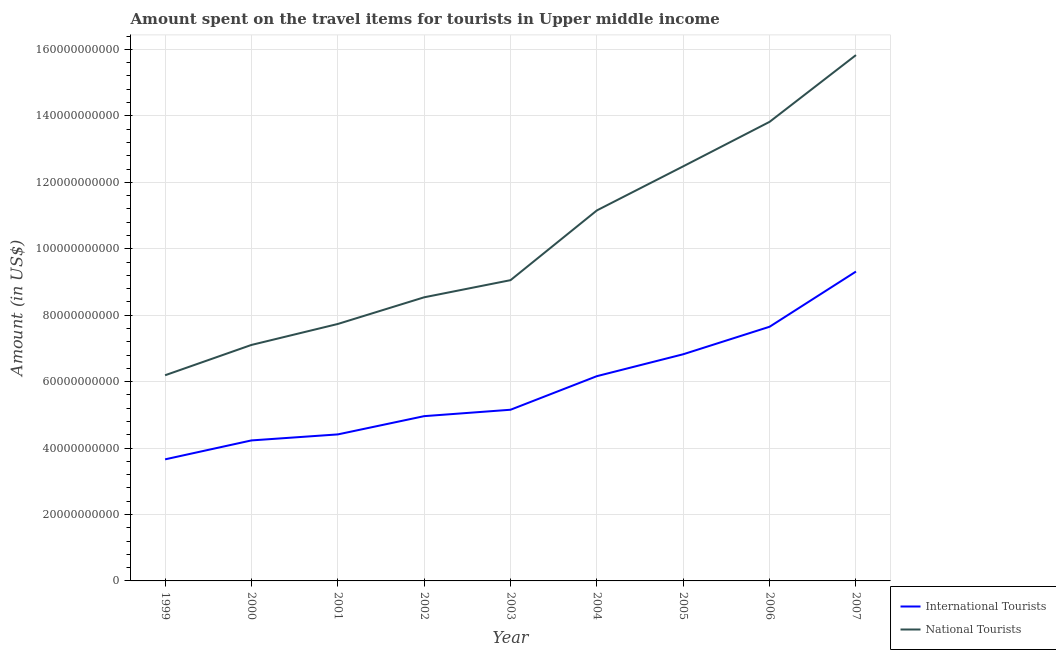Does the line corresponding to amount spent on travel items of national tourists intersect with the line corresponding to amount spent on travel items of international tourists?
Your answer should be compact. No. Is the number of lines equal to the number of legend labels?
Your answer should be compact. Yes. What is the amount spent on travel items of national tourists in 1999?
Ensure brevity in your answer.  6.19e+1. Across all years, what is the maximum amount spent on travel items of national tourists?
Make the answer very short. 1.58e+11. Across all years, what is the minimum amount spent on travel items of international tourists?
Give a very brief answer. 3.66e+1. In which year was the amount spent on travel items of international tourists maximum?
Make the answer very short. 2007. What is the total amount spent on travel items of international tourists in the graph?
Keep it short and to the point. 5.24e+11. What is the difference between the amount spent on travel items of national tourists in 2000 and that in 2002?
Provide a succinct answer. -1.43e+1. What is the difference between the amount spent on travel items of national tourists in 1999 and the amount spent on travel items of international tourists in 2000?
Offer a very short reply. 1.96e+1. What is the average amount spent on travel items of national tourists per year?
Provide a succinct answer. 1.02e+11. In the year 2003, what is the difference between the amount spent on travel items of international tourists and amount spent on travel items of national tourists?
Keep it short and to the point. -3.90e+1. What is the ratio of the amount spent on travel items of national tourists in 2003 to that in 2004?
Provide a short and direct response. 0.81. Is the difference between the amount spent on travel items of national tourists in 1999 and 2003 greater than the difference between the amount spent on travel items of international tourists in 1999 and 2003?
Ensure brevity in your answer.  No. What is the difference between the highest and the second highest amount spent on travel items of international tourists?
Your answer should be compact. 1.66e+1. What is the difference between the highest and the lowest amount spent on travel items of international tourists?
Give a very brief answer. 5.65e+1. Is the sum of the amount spent on travel items of national tourists in 2002 and 2006 greater than the maximum amount spent on travel items of international tourists across all years?
Ensure brevity in your answer.  Yes. Is the amount spent on travel items of international tourists strictly greater than the amount spent on travel items of national tourists over the years?
Offer a very short reply. No. How many lines are there?
Ensure brevity in your answer.  2. Are the values on the major ticks of Y-axis written in scientific E-notation?
Your answer should be compact. No. Does the graph contain grids?
Provide a short and direct response. Yes. What is the title of the graph?
Offer a terse response. Amount spent on the travel items for tourists in Upper middle income. What is the Amount (in US$) of International Tourists in 1999?
Ensure brevity in your answer.  3.66e+1. What is the Amount (in US$) of National Tourists in 1999?
Offer a very short reply. 6.19e+1. What is the Amount (in US$) of International Tourists in 2000?
Your response must be concise. 4.23e+1. What is the Amount (in US$) of National Tourists in 2000?
Offer a very short reply. 7.10e+1. What is the Amount (in US$) in International Tourists in 2001?
Ensure brevity in your answer.  4.41e+1. What is the Amount (in US$) in National Tourists in 2001?
Offer a very short reply. 7.74e+1. What is the Amount (in US$) in International Tourists in 2002?
Offer a very short reply. 4.96e+1. What is the Amount (in US$) in National Tourists in 2002?
Ensure brevity in your answer.  8.54e+1. What is the Amount (in US$) of International Tourists in 2003?
Offer a very short reply. 5.15e+1. What is the Amount (in US$) of National Tourists in 2003?
Offer a terse response. 9.05e+1. What is the Amount (in US$) in International Tourists in 2004?
Provide a short and direct response. 6.16e+1. What is the Amount (in US$) in National Tourists in 2004?
Make the answer very short. 1.12e+11. What is the Amount (in US$) of International Tourists in 2005?
Offer a very short reply. 6.82e+1. What is the Amount (in US$) in National Tourists in 2005?
Provide a succinct answer. 1.25e+11. What is the Amount (in US$) of International Tourists in 2006?
Provide a short and direct response. 7.65e+1. What is the Amount (in US$) of National Tourists in 2006?
Keep it short and to the point. 1.38e+11. What is the Amount (in US$) of International Tourists in 2007?
Your answer should be very brief. 9.31e+1. What is the Amount (in US$) of National Tourists in 2007?
Provide a succinct answer. 1.58e+11. Across all years, what is the maximum Amount (in US$) of International Tourists?
Your answer should be very brief. 9.31e+1. Across all years, what is the maximum Amount (in US$) of National Tourists?
Offer a very short reply. 1.58e+11. Across all years, what is the minimum Amount (in US$) of International Tourists?
Give a very brief answer. 3.66e+1. Across all years, what is the minimum Amount (in US$) in National Tourists?
Ensure brevity in your answer.  6.19e+1. What is the total Amount (in US$) of International Tourists in the graph?
Ensure brevity in your answer.  5.24e+11. What is the total Amount (in US$) of National Tourists in the graph?
Give a very brief answer. 9.19e+11. What is the difference between the Amount (in US$) of International Tourists in 1999 and that in 2000?
Your answer should be very brief. -5.70e+09. What is the difference between the Amount (in US$) of National Tourists in 1999 and that in 2000?
Keep it short and to the point. -9.13e+09. What is the difference between the Amount (in US$) of International Tourists in 1999 and that in 2001?
Offer a very short reply. -7.51e+09. What is the difference between the Amount (in US$) in National Tourists in 1999 and that in 2001?
Keep it short and to the point. -1.54e+1. What is the difference between the Amount (in US$) of International Tourists in 1999 and that in 2002?
Your answer should be very brief. -1.30e+1. What is the difference between the Amount (in US$) in National Tourists in 1999 and that in 2002?
Your response must be concise. -2.35e+1. What is the difference between the Amount (in US$) of International Tourists in 1999 and that in 2003?
Offer a very short reply. -1.49e+1. What is the difference between the Amount (in US$) of National Tourists in 1999 and that in 2003?
Keep it short and to the point. -2.86e+1. What is the difference between the Amount (in US$) of International Tourists in 1999 and that in 2004?
Keep it short and to the point. -2.50e+1. What is the difference between the Amount (in US$) of National Tourists in 1999 and that in 2004?
Make the answer very short. -4.96e+1. What is the difference between the Amount (in US$) in International Tourists in 1999 and that in 2005?
Make the answer very short. -3.16e+1. What is the difference between the Amount (in US$) of National Tourists in 1999 and that in 2005?
Offer a terse response. -6.29e+1. What is the difference between the Amount (in US$) of International Tourists in 1999 and that in 2006?
Ensure brevity in your answer.  -3.99e+1. What is the difference between the Amount (in US$) in National Tourists in 1999 and that in 2006?
Ensure brevity in your answer.  -7.63e+1. What is the difference between the Amount (in US$) in International Tourists in 1999 and that in 2007?
Your answer should be compact. -5.65e+1. What is the difference between the Amount (in US$) in National Tourists in 1999 and that in 2007?
Provide a succinct answer. -9.64e+1. What is the difference between the Amount (in US$) of International Tourists in 2000 and that in 2001?
Your answer should be compact. -1.81e+09. What is the difference between the Amount (in US$) of National Tourists in 2000 and that in 2001?
Keep it short and to the point. -6.31e+09. What is the difference between the Amount (in US$) in International Tourists in 2000 and that in 2002?
Ensure brevity in your answer.  -7.31e+09. What is the difference between the Amount (in US$) of National Tourists in 2000 and that in 2002?
Ensure brevity in your answer.  -1.43e+1. What is the difference between the Amount (in US$) of International Tourists in 2000 and that in 2003?
Keep it short and to the point. -9.23e+09. What is the difference between the Amount (in US$) of National Tourists in 2000 and that in 2003?
Offer a very short reply. -1.95e+1. What is the difference between the Amount (in US$) of International Tourists in 2000 and that in 2004?
Your answer should be very brief. -1.93e+1. What is the difference between the Amount (in US$) of National Tourists in 2000 and that in 2004?
Ensure brevity in your answer.  -4.05e+1. What is the difference between the Amount (in US$) in International Tourists in 2000 and that in 2005?
Provide a short and direct response. -2.59e+1. What is the difference between the Amount (in US$) of National Tourists in 2000 and that in 2005?
Your answer should be very brief. -5.38e+1. What is the difference between the Amount (in US$) of International Tourists in 2000 and that in 2006?
Provide a succinct answer. -3.42e+1. What is the difference between the Amount (in US$) of National Tourists in 2000 and that in 2006?
Offer a very short reply. -6.72e+1. What is the difference between the Amount (in US$) of International Tourists in 2000 and that in 2007?
Provide a short and direct response. -5.08e+1. What is the difference between the Amount (in US$) of National Tourists in 2000 and that in 2007?
Your response must be concise. -8.73e+1. What is the difference between the Amount (in US$) of International Tourists in 2001 and that in 2002?
Provide a succinct answer. -5.50e+09. What is the difference between the Amount (in US$) of National Tourists in 2001 and that in 2002?
Keep it short and to the point. -8.03e+09. What is the difference between the Amount (in US$) of International Tourists in 2001 and that in 2003?
Offer a very short reply. -7.43e+09. What is the difference between the Amount (in US$) of National Tourists in 2001 and that in 2003?
Make the answer very short. -1.32e+1. What is the difference between the Amount (in US$) in International Tourists in 2001 and that in 2004?
Your response must be concise. -1.75e+1. What is the difference between the Amount (in US$) of National Tourists in 2001 and that in 2004?
Give a very brief answer. -3.42e+1. What is the difference between the Amount (in US$) in International Tourists in 2001 and that in 2005?
Give a very brief answer. -2.41e+1. What is the difference between the Amount (in US$) of National Tourists in 2001 and that in 2005?
Keep it short and to the point. -4.75e+1. What is the difference between the Amount (in US$) in International Tourists in 2001 and that in 2006?
Your answer should be compact. -3.24e+1. What is the difference between the Amount (in US$) in National Tourists in 2001 and that in 2006?
Ensure brevity in your answer.  -6.09e+1. What is the difference between the Amount (in US$) in International Tourists in 2001 and that in 2007?
Your answer should be very brief. -4.90e+1. What is the difference between the Amount (in US$) in National Tourists in 2001 and that in 2007?
Offer a terse response. -8.09e+1. What is the difference between the Amount (in US$) of International Tourists in 2002 and that in 2003?
Your answer should be very brief. -1.93e+09. What is the difference between the Amount (in US$) of National Tourists in 2002 and that in 2003?
Ensure brevity in your answer.  -5.16e+09. What is the difference between the Amount (in US$) of International Tourists in 2002 and that in 2004?
Your answer should be compact. -1.20e+1. What is the difference between the Amount (in US$) of National Tourists in 2002 and that in 2004?
Ensure brevity in your answer.  -2.62e+1. What is the difference between the Amount (in US$) in International Tourists in 2002 and that in 2005?
Ensure brevity in your answer.  -1.86e+1. What is the difference between the Amount (in US$) of National Tourists in 2002 and that in 2005?
Ensure brevity in your answer.  -3.94e+1. What is the difference between the Amount (in US$) in International Tourists in 2002 and that in 2006?
Your answer should be very brief. -2.69e+1. What is the difference between the Amount (in US$) of National Tourists in 2002 and that in 2006?
Provide a succinct answer. -5.28e+1. What is the difference between the Amount (in US$) in International Tourists in 2002 and that in 2007?
Keep it short and to the point. -4.35e+1. What is the difference between the Amount (in US$) of National Tourists in 2002 and that in 2007?
Your answer should be compact. -7.29e+1. What is the difference between the Amount (in US$) in International Tourists in 2003 and that in 2004?
Provide a succinct answer. -1.01e+1. What is the difference between the Amount (in US$) of National Tourists in 2003 and that in 2004?
Offer a terse response. -2.10e+1. What is the difference between the Amount (in US$) of International Tourists in 2003 and that in 2005?
Offer a terse response. -1.67e+1. What is the difference between the Amount (in US$) in National Tourists in 2003 and that in 2005?
Offer a terse response. -3.43e+1. What is the difference between the Amount (in US$) of International Tourists in 2003 and that in 2006?
Make the answer very short. -2.50e+1. What is the difference between the Amount (in US$) of National Tourists in 2003 and that in 2006?
Keep it short and to the point. -4.77e+1. What is the difference between the Amount (in US$) of International Tourists in 2003 and that in 2007?
Make the answer very short. -4.16e+1. What is the difference between the Amount (in US$) in National Tourists in 2003 and that in 2007?
Provide a succinct answer. -6.78e+1. What is the difference between the Amount (in US$) of International Tourists in 2004 and that in 2005?
Keep it short and to the point. -6.59e+09. What is the difference between the Amount (in US$) in National Tourists in 2004 and that in 2005?
Your answer should be compact. -1.33e+1. What is the difference between the Amount (in US$) of International Tourists in 2004 and that in 2006?
Provide a succinct answer. -1.49e+1. What is the difference between the Amount (in US$) in National Tourists in 2004 and that in 2006?
Offer a very short reply. -2.67e+1. What is the difference between the Amount (in US$) in International Tourists in 2004 and that in 2007?
Your response must be concise. -3.15e+1. What is the difference between the Amount (in US$) of National Tourists in 2004 and that in 2007?
Ensure brevity in your answer.  -4.68e+1. What is the difference between the Amount (in US$) in International Tourists in 2005 and that in 2006?
Your answer should be compact. -8.28e+09. What is the difference between the Amount (in US$) in National Tourists in 2005 and that in 2006?
Give a very brief answer. -1.34e+1. What is the difference between the Amount (in US$) of International Tourists in 2005 and that in 2007?
Keep it short and to the point. -2.49e+1. What is the difference between the Amount (in US$) of National Tourists in 2005 and that in 2007?
Your answer should be compact. -3.35e+1. What is the difference between the Amount (in US$) of International Tourists in 2006 and that in 2007?
Ensure brevity in your answer.  -1.66e+1. What is the difference between the Amount (in US$) in National Tourists in 2006 and that in 2007?
Keep it short and to the point. -2.01e+1. What is the difference between the Amount (in US$) of International Tourists in 1999 and the Amount (in US$) of National Tourists in 2000?
Provide a short and direct response. -3.44e+1. What is the difference between the Amount (in US$) in International Tourists in 1999 and the Amount (in US$) in National Tourists in 2001?
Make the answer very short. -4.08e+1. What is the difference between the Amount (in US$) in International Tourists in 1999 and the Amount (in US$) in National Tourists in 2002?
Your answer should be very brief. -4.88e+1. What is the difference between the Amount (in US$) in International Tourists in 1999 and the Amount (in US$) in National Tourists in 2003?
Provide a succinct answer. -5.39e+1. What is the difference between the Amount (in US$) in International Tourists in 1999 and the Amount (in US$) in National Tourists in 2004?
Give a very brief answer. -7.49e+1. What is the difference between the Amount (in US$) in International Tourists in 1999 and the Amount (in US$) in National Tourists in 2005?
Provide a succinct answer. -8.82e+1. What is the difference between the Amount (in US$) in International Tourists in 1999 and the Amount (in US$) in National Tourists in 2006?
Your answer should be compact. -1.02e+11. What is the difference between the Amount (in US$) in International Tourists in 1999 and the Amount (in US$) in National Tourists in 2007?
Your answer should be compact. -1.22e+11. What is the difference between the Amount (in US$) in International Tourists in 2000 and the Amount (in US$) in National Tourists in 2001?
Make the answer very short. -3.51e+1. What is the difference between the Amount (in US$) in International Tourists in 2000 and the Amount (in US$) in National Tourists in 2002?
Provide a short and direct response. -4.31e+1. What is the difference between the Amount (in US$) in International Tourists in 2000 and the Amount (in US$) in National Tourists in 2003?
Provide a short and direct response. -4.82e+1. What is the difference between the Amount (in US$) in International Tourists in 2000 and the Amount (in US$) in National Tourists in 2004?
Give a very brief answer. -6.92e+1. What is the difference between the Amount (in US$) in International Tourists in 2000 and the Amount (in US$) in National Tourists in 2005?
Ensure brevity in your answer.  -8.25e+1. What is the difference between the Amount (in US$) in International Tourists in 2000 and the Amount (in US$) in National Tourists in 2006?
Provide a short and direct response. -9.59e+1. What is the difference between the Amount (in US$) in International Tourists in 2000 and the Amount (in US$) in National Tourists in 2007?
Ensure brevity in your answer.  -1.16e+11. What is the difference between the Amount (in US$) in International Tourists in 2001 and the Amount (in US$) in National Tourists in 2002?
Your answer should be compact. -4.13e+1. What is the difference between the Amount (in US$) of International Tourists in 2001 and the Amount (in US$) of National Tourists in 2003?
Offer a terse response. -4.64e+1. What is the difference between the Amount (in US$) in International Tourists in 2001 and the Amount (in US$) in National Tourists in 2004?
Ensure brevity in your answer.  -6.74e+1. What is the difference between the Amount (in US$) of International Tourists in 2001 and the Amount (in US$) of National Tourists in 2005?
Your answer should be compact. -8.07e+1. What is the difference between the Amount (in US$) of International Tourists in 2001 and the Amount (in US$) of National Tourists in 2006?
Provide a short and direct response. -9.41e+1. What is the difference between the Amount (in US$) of International Tourists in 2001 and the Amount (in US$) of National Tourists in 2007?
Your response must be concise. -1.14e+11. What is the difference between the Amount (in US$) in International Tourists in 2002 and the Amount (in US$) in National Tourists in 2003?
Provide a short and direct response. -4.09e+1. What is the difference between the Amount (in US$) in International Tourists in 2002 and the Amount (in US$) in National Tourists in 2004?
Ensure brevity in your answer.  -6.19e+1. What is the difference between the Amount (in US$) of International Tourists in 2002 and the Amount (in US$) of National Tourists in 2005?
Give a very brief answer. -7.52e+1. What is the difference between the Amount (in US$) of International Tourists in 2002 and the Amount (in US$) of National Tourists in 2006?
Offer a terse response. -8.86e+1. What is the difference between the Amount (in US$) in International Tourists in 2002 and the Amount (in US$) in National Tourists in 2007?
Your answer should be very brief. -1.09e+11. What is the difference between the Amount (in US$) in International Tourists in 2003 and the Amount (in US$) in National Tourists in 2004?
Your answer should be very brief. -6.00e+1. What is the difference between the Amount (in US$) of International Tourists in 2003 and the Amount (in US$) of National Tourists in 2005?
Offer a very short reply. -7.33e+1. What is the difference between the Amount (in US$) of International Tourists in 2003 and the Amount (in US$) of National Tourists in 2006?
Your answer should be very brief. -8.67e+1. What is the difference between the Amount (in US$) of International Tourists in 2003 and the Amount (in US$) of National Tourists in 2007?
Ensure brevity in your answer.  -1.07e+11. What is the difference between the Amount (in US$) of International Tourists in 2004 and the Amount (in US$) of National Tourists in 2005?
Ensure brevity in your answer.  -6.32e+1. What is the difference between the Amount (in US$) of International Tourists in 2004 and the Amount (in US$) of National Tourists in 2006?
Your answer should be compact. -7.66e+1. What is the difference between the Amount (in US$) in International Tourists in 2004 and the Amount (in US$) in National Tourists in 2007?
Keep it short and to the point. -9.67e+1. What is the difference between the Amount (in US$) of International Tourists in 2005 and the Amount (in US$) of National Tourists in 2006?
Make the answer very short. -7.00e+1. What is the difference between the Amount (in US$) in International Tourists in 2005 and the Amount (in US$) in National Tourists in 2007?
Provide a succinct answer. -9.01e+1. What is the difference between the Amount (in US$) of International Tourists in 2006 and the Amount (in US$) of National Tourists in 2007?
Ensure brevity in your answer.  -8.18e+1. What is the average Amount (in US$) of International Tourists per year?
Your answer should be very brief. 5.82e+1. What is the average Amount (in US$) of National Tourists per year?
Provide a succinct answer. 1.02e+11. In the year 1999, what is the difference between the Amount (in US$) of International Tourists and Amount (in US$) of National Tourists?
Provide a short and direct response. -2.53e+1. In the year 2000, what is the difference between the Amount (in US$) of International Tourists and Amount (in US$) of National Tourists?
Keep it short and to the point. -2.87e+1. In the year 2001, what is the difference between the Amount (in US$) in International Tourists and Amount (in US$) in National Tourists?
Give a very brief answer. -3.32e+1. In the year 2002, what is the difference between the Amount (in US$) in International Tourists and Amount (in US$) in National Tourists?
Your response must be concise. -3.58e+1. In the year 2003, what is the difference between the Amount (in US$) in International Tourists and Amount (in US$) in National Tourists?
Your response must be concise. -3.90e+1. In the year 2004, what is the difference between the Amount (in US$) in International Tourists and Amount (in US$) in National Tourists?
Give a very brief answer. -4.99e+1. In the year 2005, what is the difference between the Amount (in US$) of International Tourists and Amount (in US$) of National Tourists?
Your answer should be very brief. -5.66e+1. In the year 2006, what is the difference between the Amount (in US$) in International Tourists and Amount (in US$) in National Tourists?
Your answer should be very brief. -6.17e+1. In the year 2007, what is the difference between the Amount (in US$) of International Tourists and Amount (in US$) of National Tourists?
Keep it short and to the point. -6.52e+1. What is the ratio of the Amount (in US$) in International Tourists in 1999 to that in 2000?
Keep it short and to the point. 0.87. What is the ratio of the Amount (in US$) in National Tourists in 1999 to that in 2000?
Keep it short and to the point. 0.87. What is the ratio of the Amount (in US$) of International Tourists in 1999 to that in 2001?
Provide a short and direct response. 0.83. What is the ratio of the Amount (in US$) in National Tourists in 1999 to that in 2001?
Offer a very short reply. 0.8. What is the ratio of the Amount (in US$) in International Tourists in 1999 to that in 2002?
Ensure brevity in your answer.  0.74. What is the ratio of the Amount (in US$) of National Tourists in 1999 to that in 2002?
Your response must be concise. 0.73. What is the ratio of the Amount (in US$) in International Tourists in 1999 to that in 2003?
Make the answer very short. 0.71. What is the ratio of the Amount (in US$) in National Tourists in 1999 to that in 2003?
Make the answer very short. 0.68. What is the ratio of the Amount (in US$) of International Tourists in 1999 to that in 2004?
Make the answer very short. 0.59. What is the ratio of the Amount (in US$) in National Tourists in 1999 to that in 2004?
Offer a terse response. 0.56. What is the ratio of the Amount (in US$) of International Tourists in 1999 to that in 2005?
Ensure brevity in your answer.  0.54. What is the ratio of the Amount (in US$) of National Tourists in 1999 to that in 2005?
Ensure brevity in your answer.  0.5. What is the ratio of the Amount (in US$) of International Tourists in 1999 to that in 2006?
Provide a short and direct response. 0.48. What is the ratio of the Amount (in US$) in National Tourists in 1999 to that in 2006?
Give a very brief answer. 0.45. What is the ratio of the Amount (in US$) of International Tourists in 1999 to that in 2007?
Provide a short and direct response. 0.39. What is the ratio of the Amount (in US$) in National Tourists in 1999 to that in 2007?
Keep it short and to the point. 0.39. What is the ratio of the Amount (in US$) in International Tourists in 2000 to that in 2001?
Give a very brief answer. 0.96. What is the ratio of the Amount (in US$) in National Tourists in 2000 to that in 2001?
Your answer should be compact. 0.92. What is the ratio of the Amount (in US$) in International Tourists in 2000 to that in 2002?
Provide a short and direct response. 0.85. What is the ratio of the Amount (in US$) in National Tourists in 2000 to that in 2002?
Make the answer very short. 0.83. What is the ratio of the Amount (in US$) in International Tourists in 2000 to that in 2003?
Give a very brief answer. 0.82. What is the ratio of the Amount (in US$) of National Tourists in 2000 to that in 2003?
Provide a succinct answer. 0.78. What is the ratio of the Amount (in US$) in International Tourists in 2000 to that in 2004?
Your answer should be very brief. 0.69. What is the ratio of the Amount (in US$) of National Tourists in 2000 to that in 2004?
Give a very brief answer. 0.64. What is the ratio of the Amount (in US$) in International Tourists in 2000 to that in 2005?
Make the answer very short. 0.62. What is the ratio of the Amount (in US$) of National Tourists in 2000 to that in 2005?
Give a very brief answer. 0.57. What is the ratio of the Amount (in US$) of International Tourists in 2000 to that in 2006?
Your response must be concise. 0.55. What is the ratio of the Amount (in US$) in National Tourists in 2000 to that in 2006?
Give a very brief answer. 0.51. What is the ratio of the Amount (in US$) of International Tourists in 2000 to that in 2007?
Ensure brevity in your answer.  0.45. What is the ratio of the Amount (in US$) in National Tourists in 2000 to that in 2007?
Your answer should be compact. 0.45. What is the ratio of the Amount (in US$) in International Tourists in 2001 to that in 2002?
Your answer should be very brief. 0.89. What is the ratio of the Amount (in US$) of National Tourists in 2001 to that in 2002?
Your response must be concise. 0.91. What is the ratio of the Amount (in US$) of International Tourists in 2001 to that in 2003?
Offer a terse response. 0.86. What is the ratio of the Amount (in US$) of National Tourists in 2001 to that in 2003?
Your response must be concise. 0.85. What is the ratio of the Amount (in US$) in International Tourists in 2001 to that in 2004?
Keep it short and to the point. 0.72. What is the ratio of the Amount (in US$) of National Tourists in 2001 to that in 2004?
Make the answer very short. 0.69. What is the ratio of the Amount (in US$) of International Tourists in 2001 to that in 2005?
Provide a short and direct response. 0.65. What is the ratio of the Amount (in US$) in National Tourists in 2001 to that in 2005?
Ensure brevity in your answer.  0.62. What is the ratio of the Amount (in US$) of International Tourists in 2001 to that in 2006?
Your answer should be compact. 0.58. What is the ratio of the Amount (in US$) in National Tourists in 2001 to that in 2006?
Keep it short and to the point. 0.56. What is the ratio of the Amount (in US$) in International Tourists in 2001 to that in 2007?
Ensure brevity in your answer.  0.47. What is the ratio of the Amount (in US$) in National Tourists in 2001 to that in 2007?
Provide a short and direct response. 0.49. What is the ratio of the Amount (in US$) in International Tourists in 2002 to that in 2003?
Ensure brevity in your answer.  0.96. What is the ratio of the Amount (in US$) in National Tourists in 2002 to that in 2003?
Make the answer very short. 0.94. What is the ratio of the Amount (in US$) in International Tourists in 2002 to that in 2004?
Give a very brief answer. 0.8. What is the ratio of the Amount (in US$) of National Tourists in 2002 to that in 2004?
Keep it short and to the point. 0.77. What is the ratio of the Amount (in US$) in International Tourists in 2002 to that in 2005?
Your answer should be very brief. 0.73. What is the ratio of the Amount (in US$) in National Tourists in 2002 to that in 2005?
Your answer should be very brief. 0.68. What is the ratio of the Amount (in US$) of International Tourists in 2002 to that in 2006?
Provide a short and direct response. 0.65. What is the ratio of the Amount (in US$) in National Tourists in 2002 to that in 2006?
Provide a succinct answer. 0.62. What is the ratio of the Amount (in US$) in International Tourists in 2002 to that in 2007?
Make the answer very short. 0.53. What is the ratio of the Amount (in US$) in National Tourists in 2002 to that in 2007?
Keep it short and to the point. 0.54. What is the ratio of the Amount (in US$) of International Tourists in 2003 to that in 2004?
Give a very brief answer. 0.84. What is the ratio of the Amount (in US$) of National Tourists in 2003 to that in 2004?
Your answer should be very brief. 0.81. What is the ratio of the Amount (in US$) of International Tourists in 2003 to that in 2005?
Ensure brevity in your answer.  0.76. What is the ratio of the Amount (in US$) in National Tourists in 2003 to that in 2005?
Your response must be concise. 0.73. What is the ratio of the Amount (in US$) of International Tourists in 2003 to that in 2006?
Ensure brevity in your answer.  0.67. What is the ratio of the Amount (in US$) in National Tourists in 2003 to that in 2006?
Make the answer very short. 0.66. What is the ratio of the Amount (in US$) of International Tourists in 2003 to that in 2007?
Give a very brief answer. 0.55. What is the ratio of the Amount (in US$) in National Tourists in 2003 to that in 2007?
Provide a short and direct response. 0.57. What is the ratio of the Amount (in US$) in International Tourists in 2004 to that in 2005?
Make the answer very short. 0.9. What is the ratio of the Amount (in US$) in National Tourists in 2004 to that in 2005?
Provide a short and direct response. 0.89. What is the ratio of the Amount (in US$) in International Tourists in 2004 to that in 2006?
Offer a very short reply. 0.81. What is the ratio of the Amount (in US$) in National Tourists in 2004 to that in 2006?
Give a very brief answer. 0.81. What is the ratio of the Amount (in US$) of International Tourists in 2004 to that in 2007?
Offer a very short reply. 0.66. What is the ratio of the Amount (in US$) in National Tourists in 2004 to that in 2007?
Provide a succinct answer. 0.7. What is the ratio of the Amount (in US$) in International Tourists in 2005 to that in 2006?
Offer a very short reply. 0.89. What is the ratio of the Amount (in US$) in National Tourists in 2005 to that in 2006?
Provide a succinct answer. 0.9. What is the ratio of the Amount (in US$) of International Tourists in 2005 to that in 2007?
Provide a succinct answer. 0.73. What is the ratio of the Amount (in US$) in National Tourists in 2005 to that in 2007?
Ensure brevity in your answer.  0.79. What is the ratio of the Amount (in US$) of International Tourists in 2006 to that in 2007?
Your answer should be very brief. 0.82. What is the ratio of the Amount (in US$) in National Tourists in 2006 to that in 2007?
Ensure brevity in your answer.  0.87. What is the difference between the highest and the second highest Amount (in US$) of International Tourists?
Provide a succinct answer. 1.66e+1. What is the difference between the highest and the second highest Amount (in US$) in National Tourists?
Keep it short and to the point. 2.01e+1. What is the difference between the highest and the lowest Amount (in US$) of International Tourists?
Provide a short and direct response. 5.65e+1. What is the difference between the highest and the lowest Amount (in US$) in National Tourists?
Your answer should be very brief. 9.64e+1. 